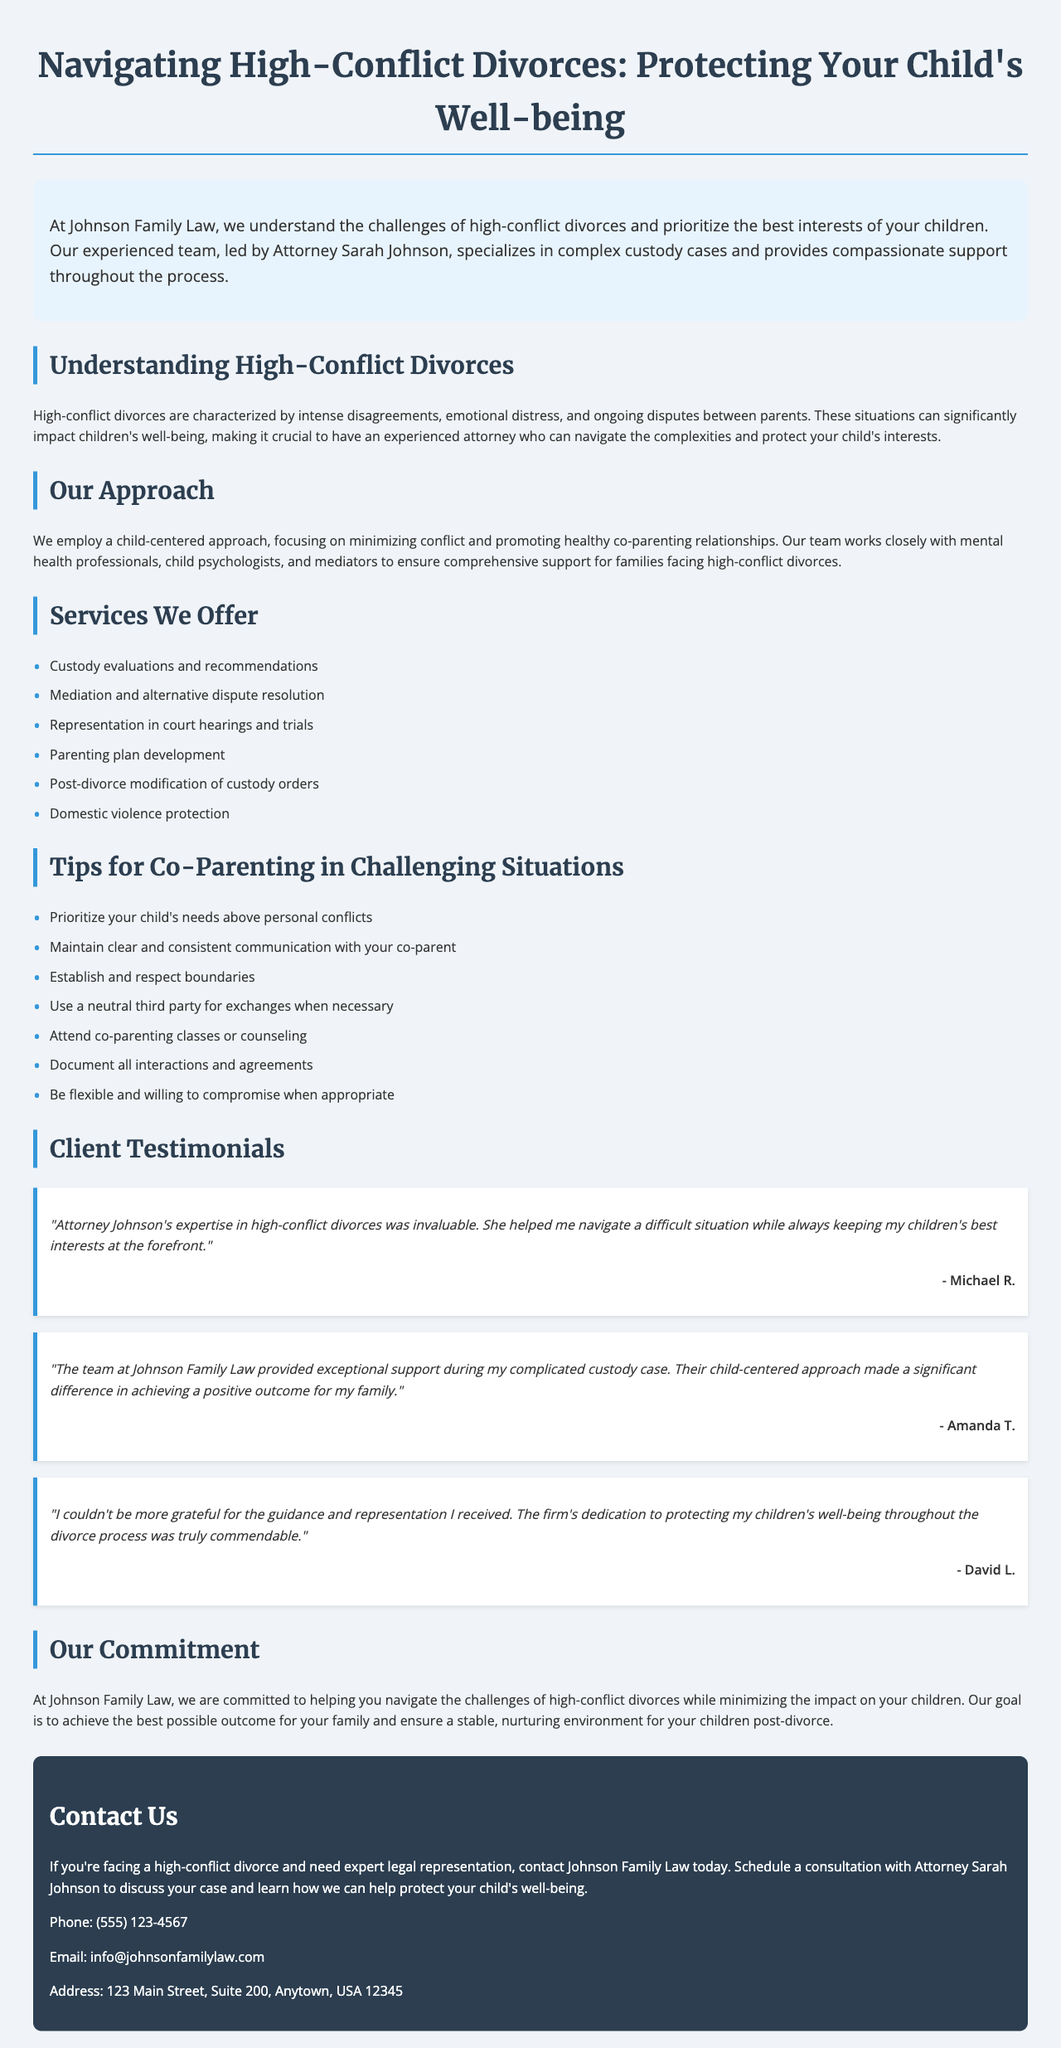What is the title of the brochure? The title is indicated at the top of the brochure, which summarizes its content.
Answer: Navigating High-Conflict Divorces: Protecting Your Child's Well-being Who leads the team at Johnson Family Law? The document mentions the leader of the team, highlighting their expertise.
Answer: Attorney Sarah Johnson What is one of the services offered by Johnson Family Law? The brochure lists various services provided; one example represents their capabilities.
Answer: Custody evaluations and recommendations How many testimonials are included in the brochure? The testimonials section lists individual client experiences, which can be counted.
Answer: Three What is one tip provided for co-parenting in challenging situations? The document offers specific suggestions to assist in co-parenting during difficulties.
Answer: Prioritize your child's needs above personal conflicts In what type of divorce does Johnson Family Law specialize? The introductory section of the brochure specifies the focus area for the firm.
Answer: High-conflict divorces What is the phone number provided for contacting Johnson Family Law? The contact section gives all necessary contact information, including phone details.
Answer: (555) 123-4567 What is the main commitment of Johnson Family Law? The commitment section highlights the firm's focus in helping clients during the process.
Answer: Helping you navigate the challenges of high-conflict divorces What approach does Johnson Family Law employ in their practice? The approach section explains the methodology used by the firm in their cases.
Answer: Child-centered approach 